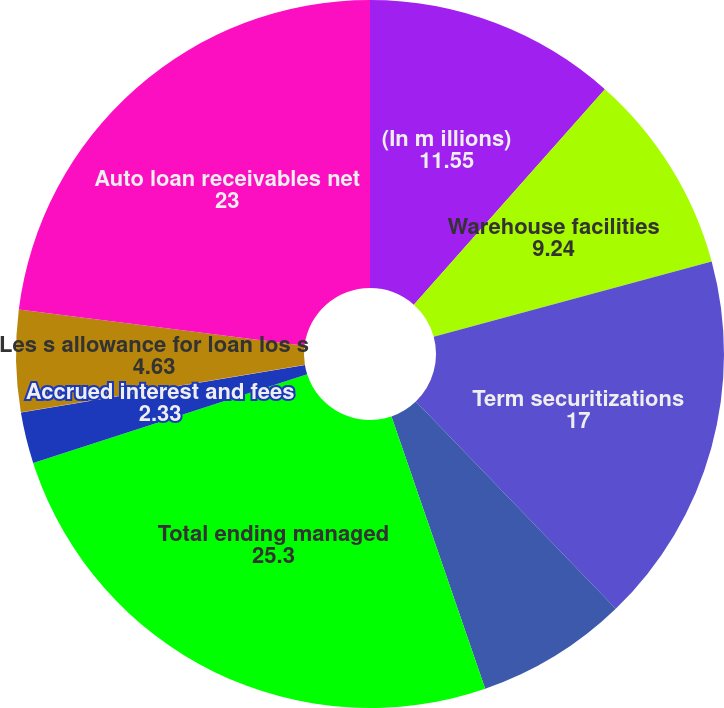Convert chart to OTSL. <chart><loc_0><loc_0><loc_500><loc_500><pie_chart><fcel>(In m illions)<fcel>Warehouse facilities<fcel>Term securitizations<fcel>Other receivables (1)<fcel>Total ending managed<fcel>Accrued interest and fees<fcel>Other<fcel>Les s allowance for loan los s<fcel>Auto loan receivables net<nl><fcel>11.55%<fcel>9.24%<fcel>17.0%<fcel>6.94%<fcel>25.3%<fcel>2.33%<fcel>0.02%<fcel>4.63%<fcel>23.0%<nl></chart> 